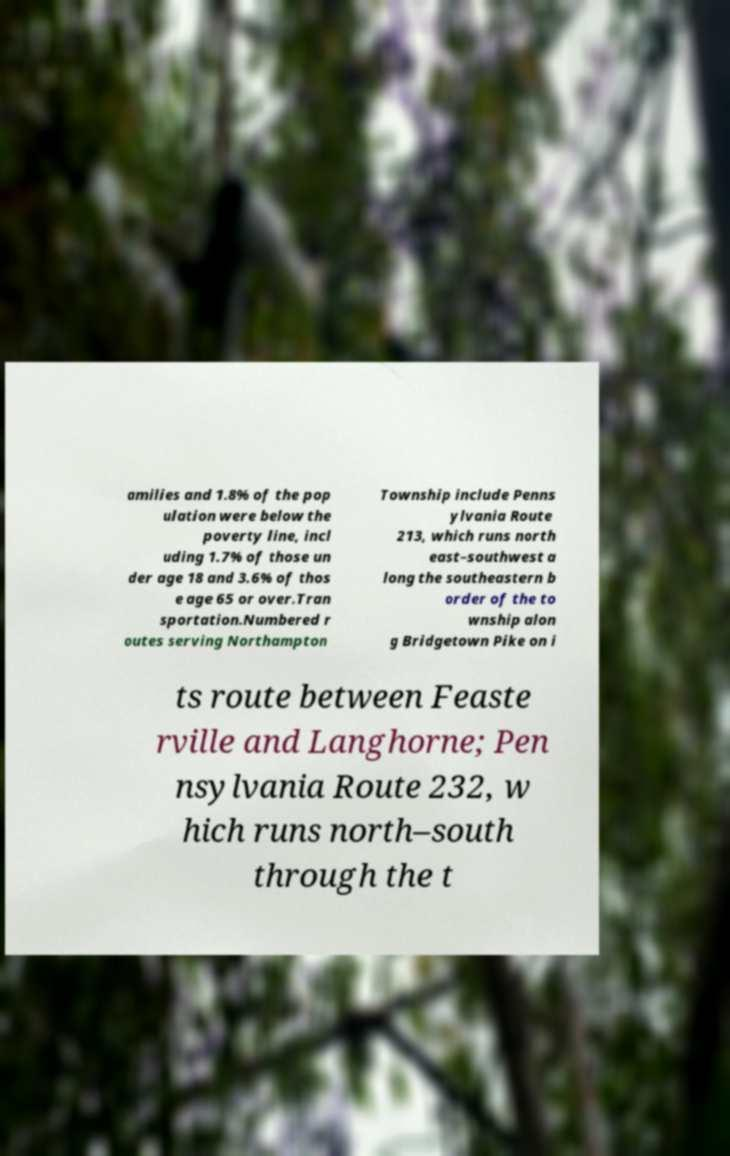I need the written content from this picture converted into text. Can you do that? amilies and 1.8% of the pop ulation were below the poverty line, incl uding 1.7% of those un der age 18 and 3.6% of thos e age 65 or over.Tran sportation.Numbered r outes serving Northampton Township include Penns ylvania Route 213, which runs north east–southwest a long the southeastern b order of the to wnship alon g Bridgetown Pike on i ts route between Feaste rville and Langhorne; Pen nsylvania Route 232, w hich runs north–south through the t 